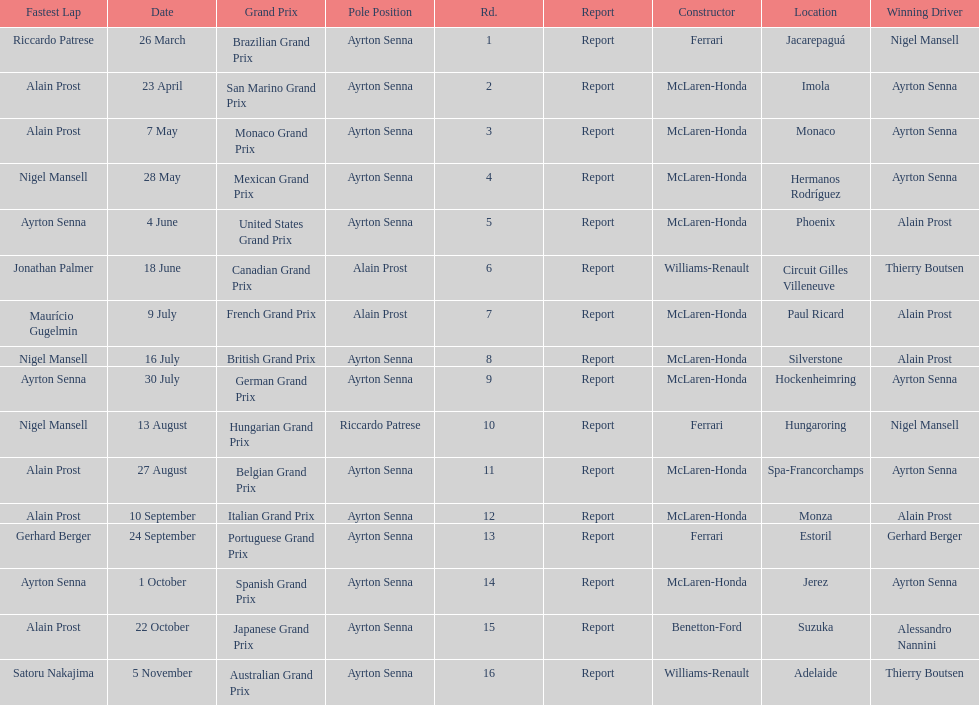Prost won the drivers title, who was his teammate? Ayrton Senna. 